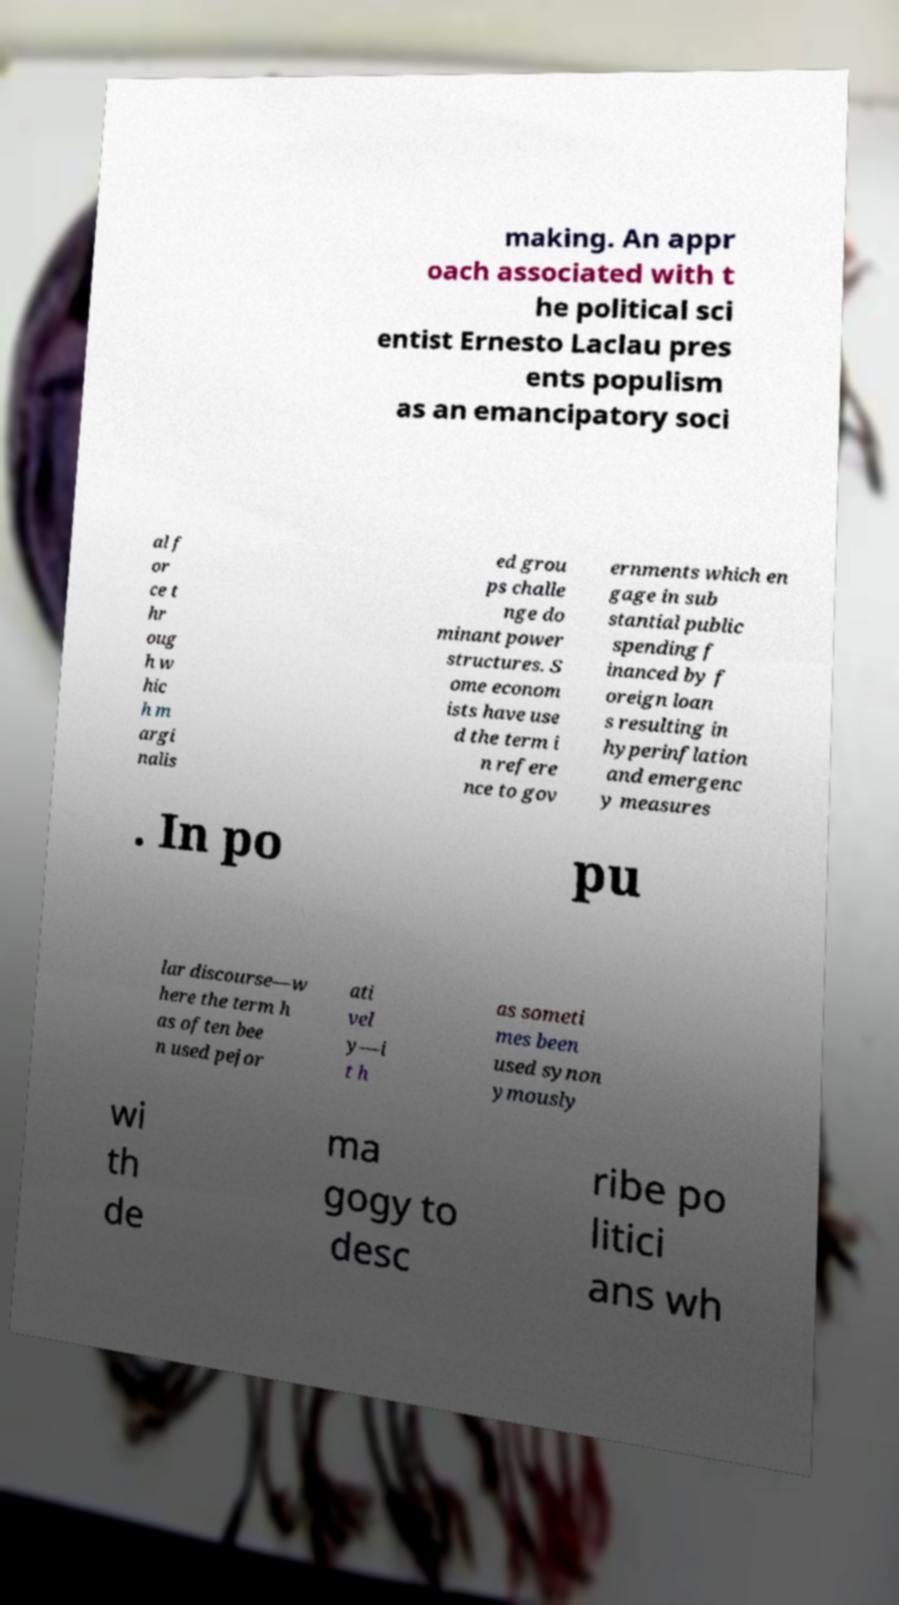Can you read and provide the text displayed in the image?This photo seems to have some interesting text. Can you extract and type it out for me? making. An appr oach associated with t he political sci entist Ernesto Laclau pres ents populism as an emancipatory soci al f or ce t hr oug h w hic h m argi nalis ed grou ps challe nge do minant power structures. S ome econom ists have use d the term i n refere nce to gov ernments which en gage in sub stantial public spending f inanced by f oreign loan s resulting in hyperinflation and emergenc y measures . In po pu lar discourse—w here the term h as often bee n used pejor ati vel y—i t h as someti mes been used synon ymously wi th de ma gogy to desc ribe po litici ans wh 